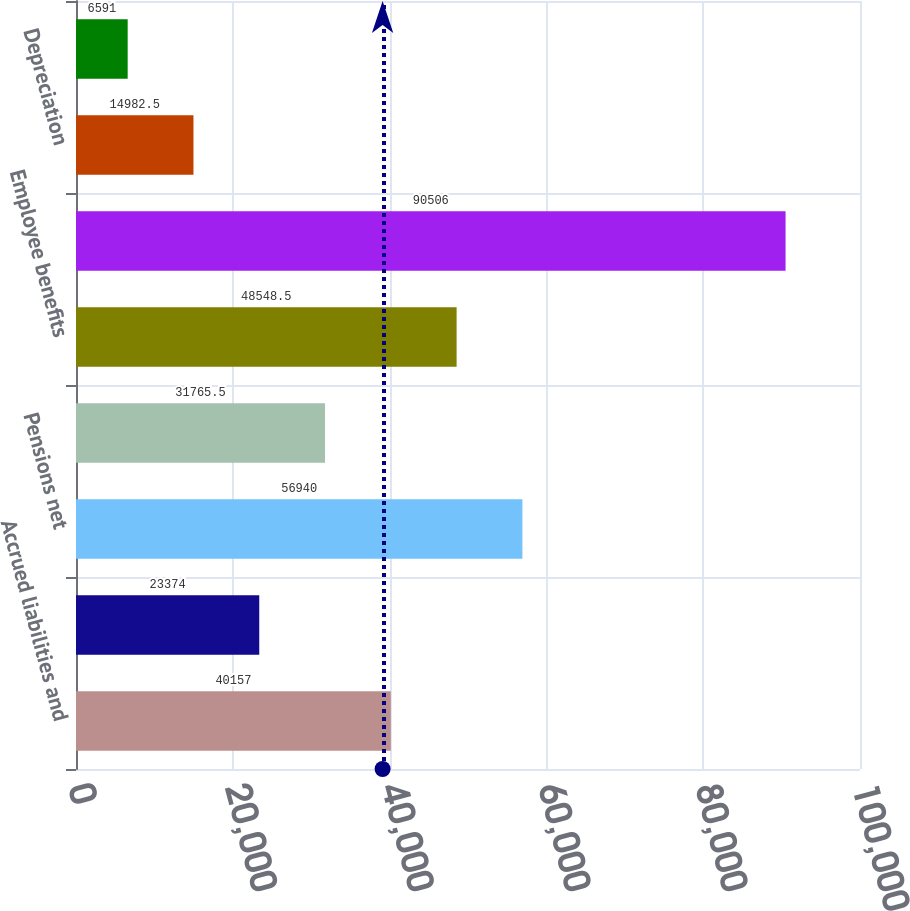<chart> <loc_0><loc_0><loc_500><loc_500><bar_chart><fcel>Accrued liabilities and<fcel>Operating loss and tax credit<fcel>Pensions net<fcel>Inventory reserves<fcel>Employee benefits<fcel>Goodwill<fcel>Depreciation<fcel>Contingent consideration<nl><fcel>40157<fcel>23374<fcel>56940<fcel>31765.5<fcel>48548.5<fcel>90506<fcel>14982.5<fcel>6591<nl></chart> 